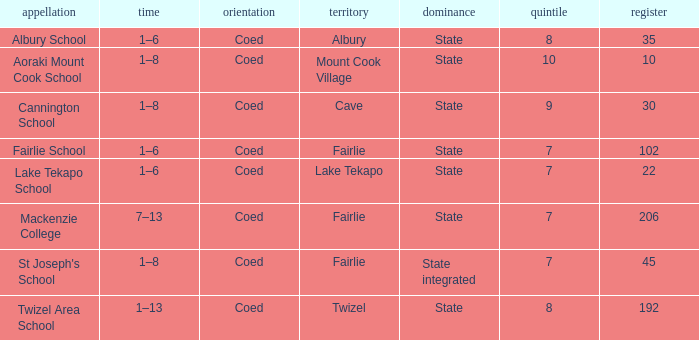Parse the table in full. {'header': ['appellation', 'time', 'orientation', 'territory', 'dominance', 'quintile', 'register'], 'rows': [['Albury School', '1–6', 'Coed', 'Albury', 'State', '8', '35'], ['Aoraki Mount Cook School', '1–8', 'Coed', 'Mount Cook Village', 'State', '10', '10'], ['Cannington School', '1–8', 'Coed', 'Cave', 'State', '9', '30'], ['Fairlie School', '1–6', 'Coed', 'Fairlie', 'State', '7', '102'], ['Lake Tekapo School', '1–6', 'Coed', 'Lake Tekapo', 'State', '7', '22'], ['Mackenzie College', '7–13', 'Coed', 'Fairlie', 'State', '7', '206'], ["St Joseph's School", '1–8', 'Coed', 'Fairlie', 'State integrated', '7', '45'], ['Twizel Area School', '1–13', 'Coed', 'Twizel', 'State', '8', '192']]} What area is named Mackenzie college? Fairlie. 